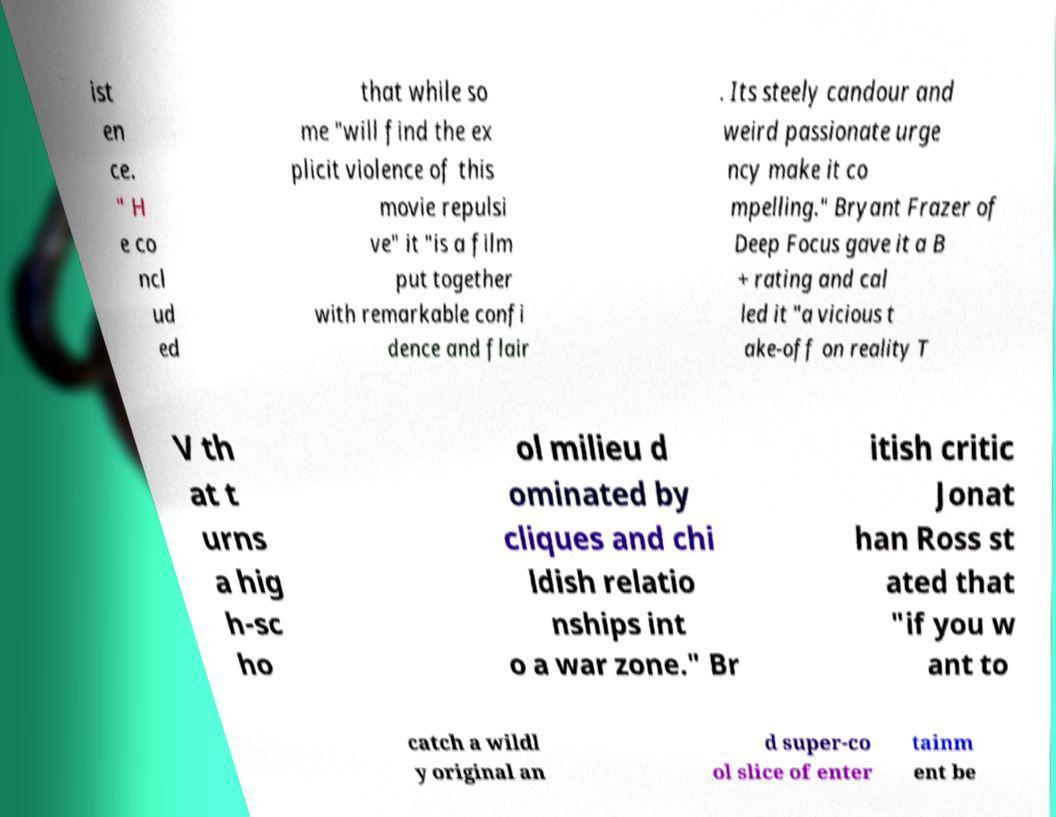Can you accurately transcribe the text from the provided image for me? ist en ce. " H e co ncl ud ed that while so me "will find the ex plicit violence of this movie repulsi ve" it "is a film put together with remarkable confi dence and flair . Its steely candour and weird passionate urge ncy make it co mpelling." Bryant Frazer of Deep Focus gave it a B + rating and cal led it "a vicious t ake-off on reality T V th at t urns a hig h-sc ho ol milieu d ominated by cliques and chi ldish relatio nships int o a war zone." Br itish critic Jonat han Ross st ated that "if you w ant to catch a wildl y original an d super-co ol slice of enter tainm ent be 